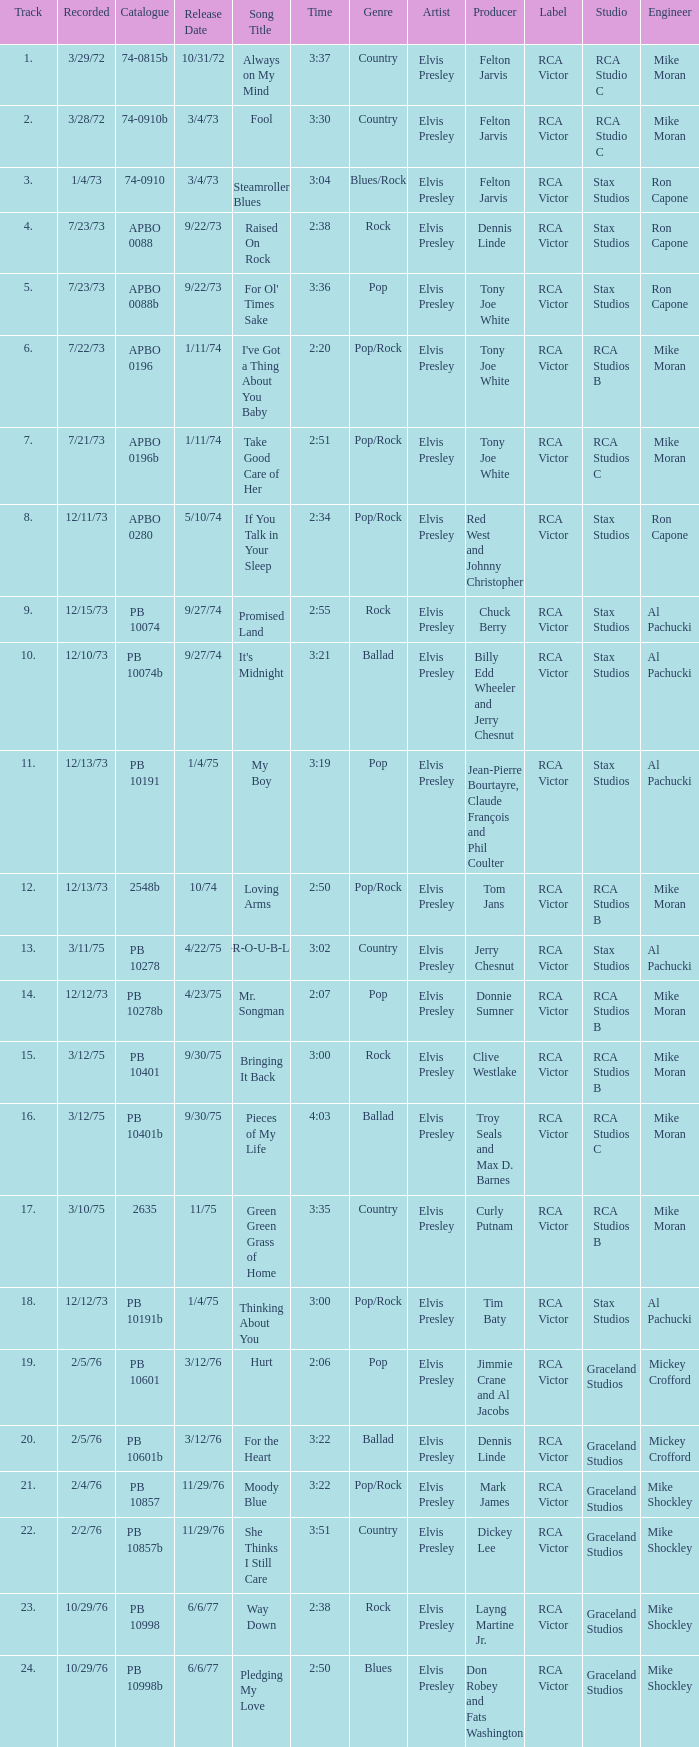How many tracks are there in raised on rock? 4.0. 